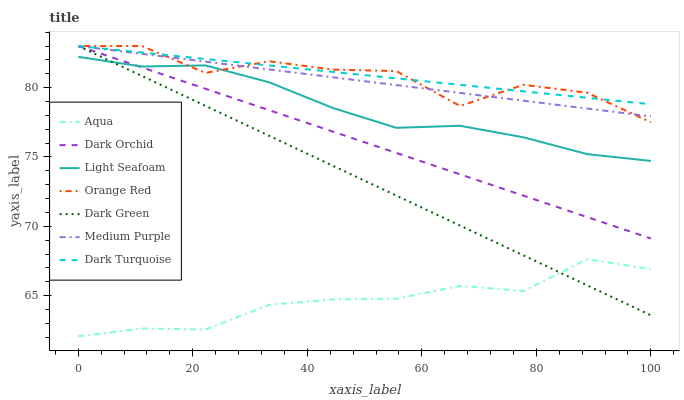Does Aqua have the minimum area under the curve?
Answer yes or no. Yes. Does Dark Turquoise have the maximum area under the curve?
Answer yes or no. Yes. Does Dark Orchid have the minimum area under the curve?
Answer yes or no. No. Does Dark Orchid have the maximum area under the curve?
Answer yes or no. No. Is Dark Green the smoothest?
Answer yes or no. Yes. Is Orange Red the roughest?
Answer yes or no. Yes. Is Aqua the smoothest?
Answer yes or no. No. Is Aqua the roughest?
Answer yes or no. No. Does Dark Orchid have the lowest value?
Answer yes or no. No. Does Aqua have the highest value?
Answer yes or no. No. Is Aqua less than Light Seafoam?
Answer yes or no. Yes. Is Dark Turquoise greater than Aqua?
Answer yes or no. Yes. Does Aqua intersect Light Seafoam?
Answer yes or no. No. 